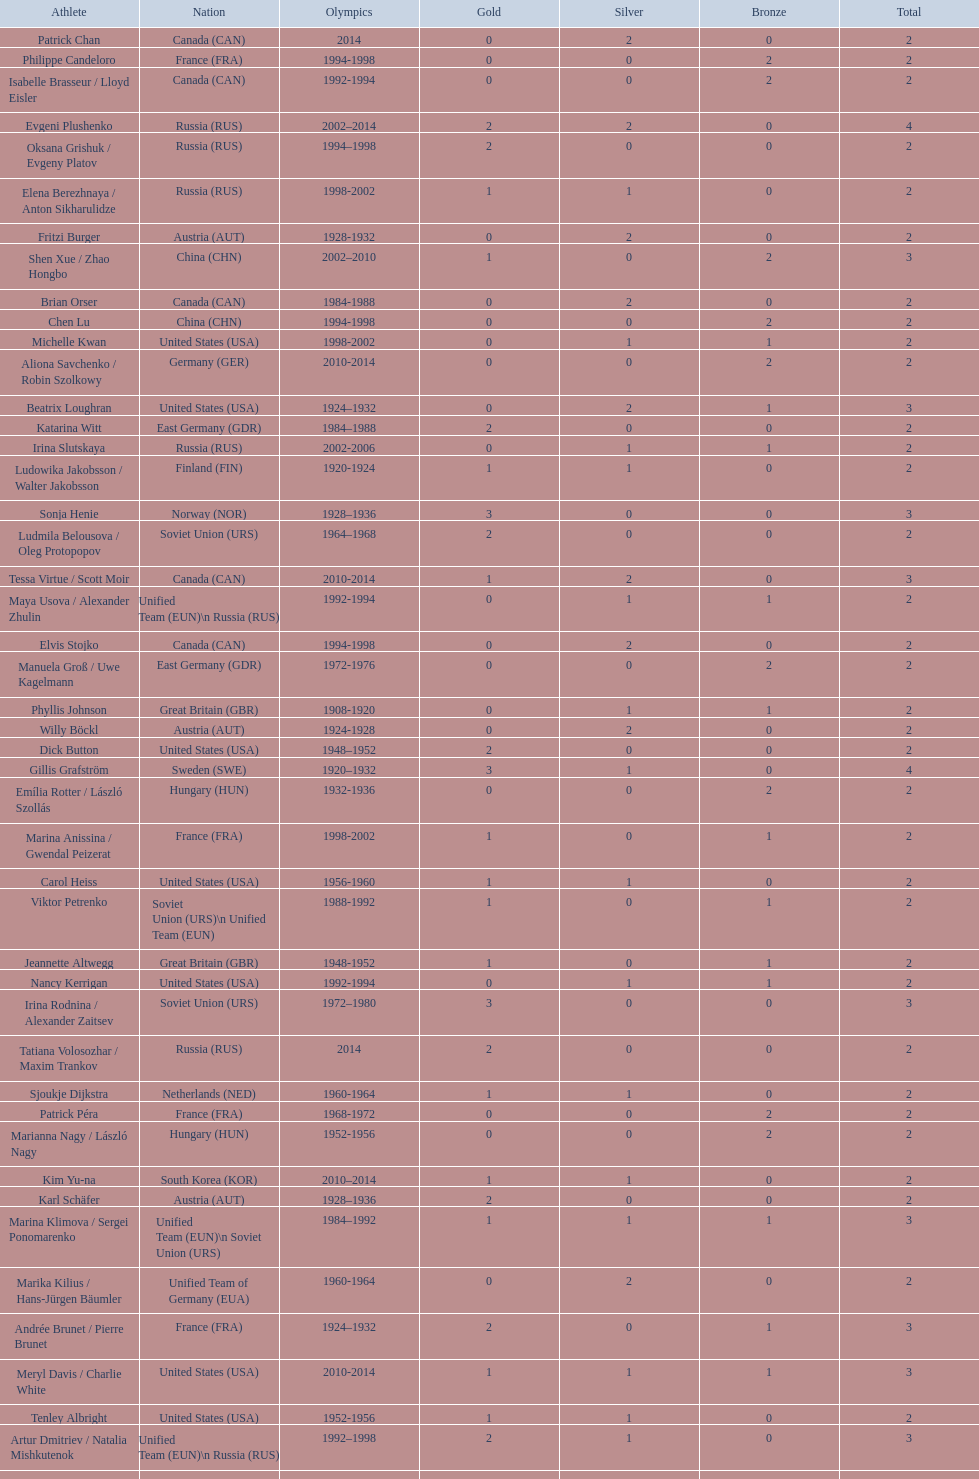What was the greatest number of gold medals won by a single athlete? 3. 